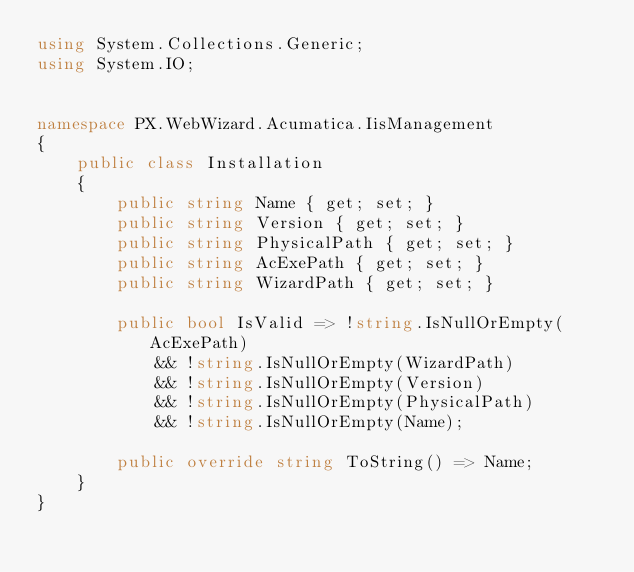Convert code to text. <code><loc_0><loc_0><loc_500><loc_500><_C#_>using System.Collections.Generic;
using System.IO;


namespace PX.WebWizard.Acumatica.IisManagement
{
    public class Installation
    {
        public string Name { get; set; }
        public string Version { get; set; }
        public string PhysicalPath { get; set; }
        public string AcExePath { get; set; }
        public string WizardPath { get; set; }

        public bool IsValid => !string.IsNullOrEmpty(AcExePath)
            && !string.IsNullOrEmpty(WizardPath)
            && !string.IsNullOrEmpty(Version)
            && !string.IsNullOrEmpty(PhysicalPath)
            && !string.IsNullOrEmpty(Name);

        public override string ToString() => Name;
    }
}
</code> 